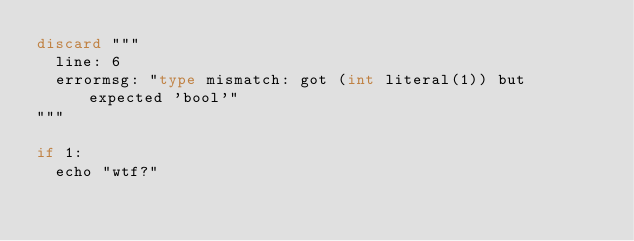Convert code to text. <code><loc_0><loc_0><loc_500><loc_500><_Nim_>discard """
  line: 6
  errormsg: "type mismatch: got (int literal(1)) but expected 'bool'"
"""

if 1: 
  echo "wtf?"
  
</code> 